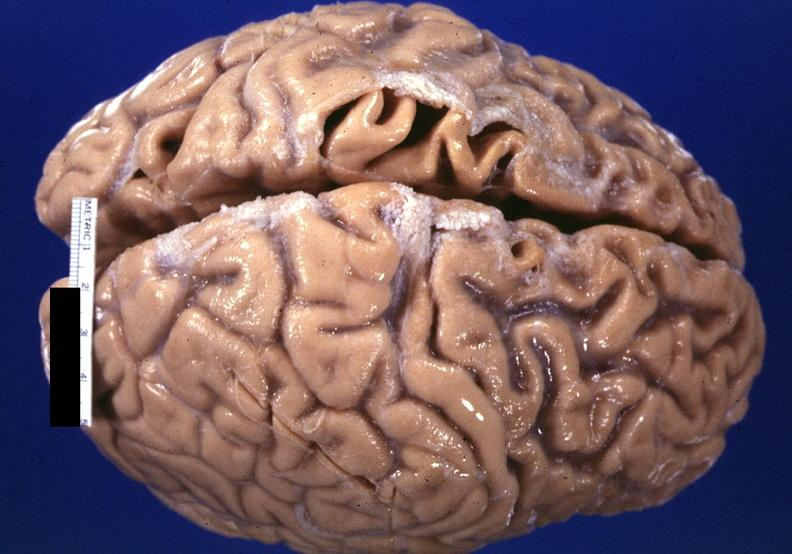does this image show brain, frontal lobe atrophy, pick 's disease?
Answer the question using a single word or phrase. Yes 